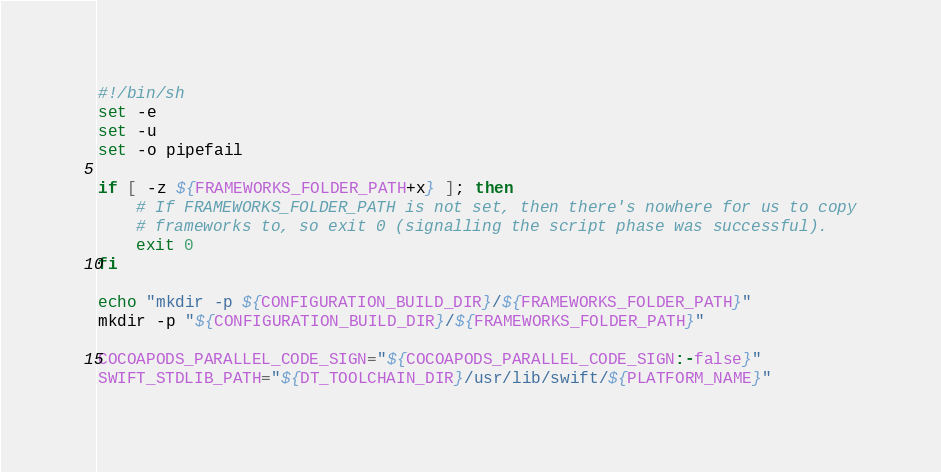<code> <loc_0><loc_0><loc_500><loc_500><_Bash_>#!/bin/sh
set -e
set -u
set -o pipefail

if [ -z ${FRAMEWORKS_FOLDER_PATH+x} ]; then
    # If FRAMEWORKS_FOLDER_PATH is not set, then there's nowhere for us to copy
    # frameworks to, so exit 0 (signalling the script phase was successful).
    exit 0
fi

echo "mkdir -p ${CONFIGURATION_BUILD_DIR}/${FRAMEWORKS_FOLDER_PATH}"
mkdir -p "${CONFIGURATION_BUILD_DIR}/${FRAMEWORKS_FOLDER_PATH}"

COCOAPODS_PARALLEL_CODE_SIGN="${COCOAPODS_PARALLEL_CODE_SIGN:-false}"
SWIFT_STDLIB_PATH="${DT_TOOLCHAIN_DIR}/usr/lib/swift/${PLATFORM_NAME}"
</code> 